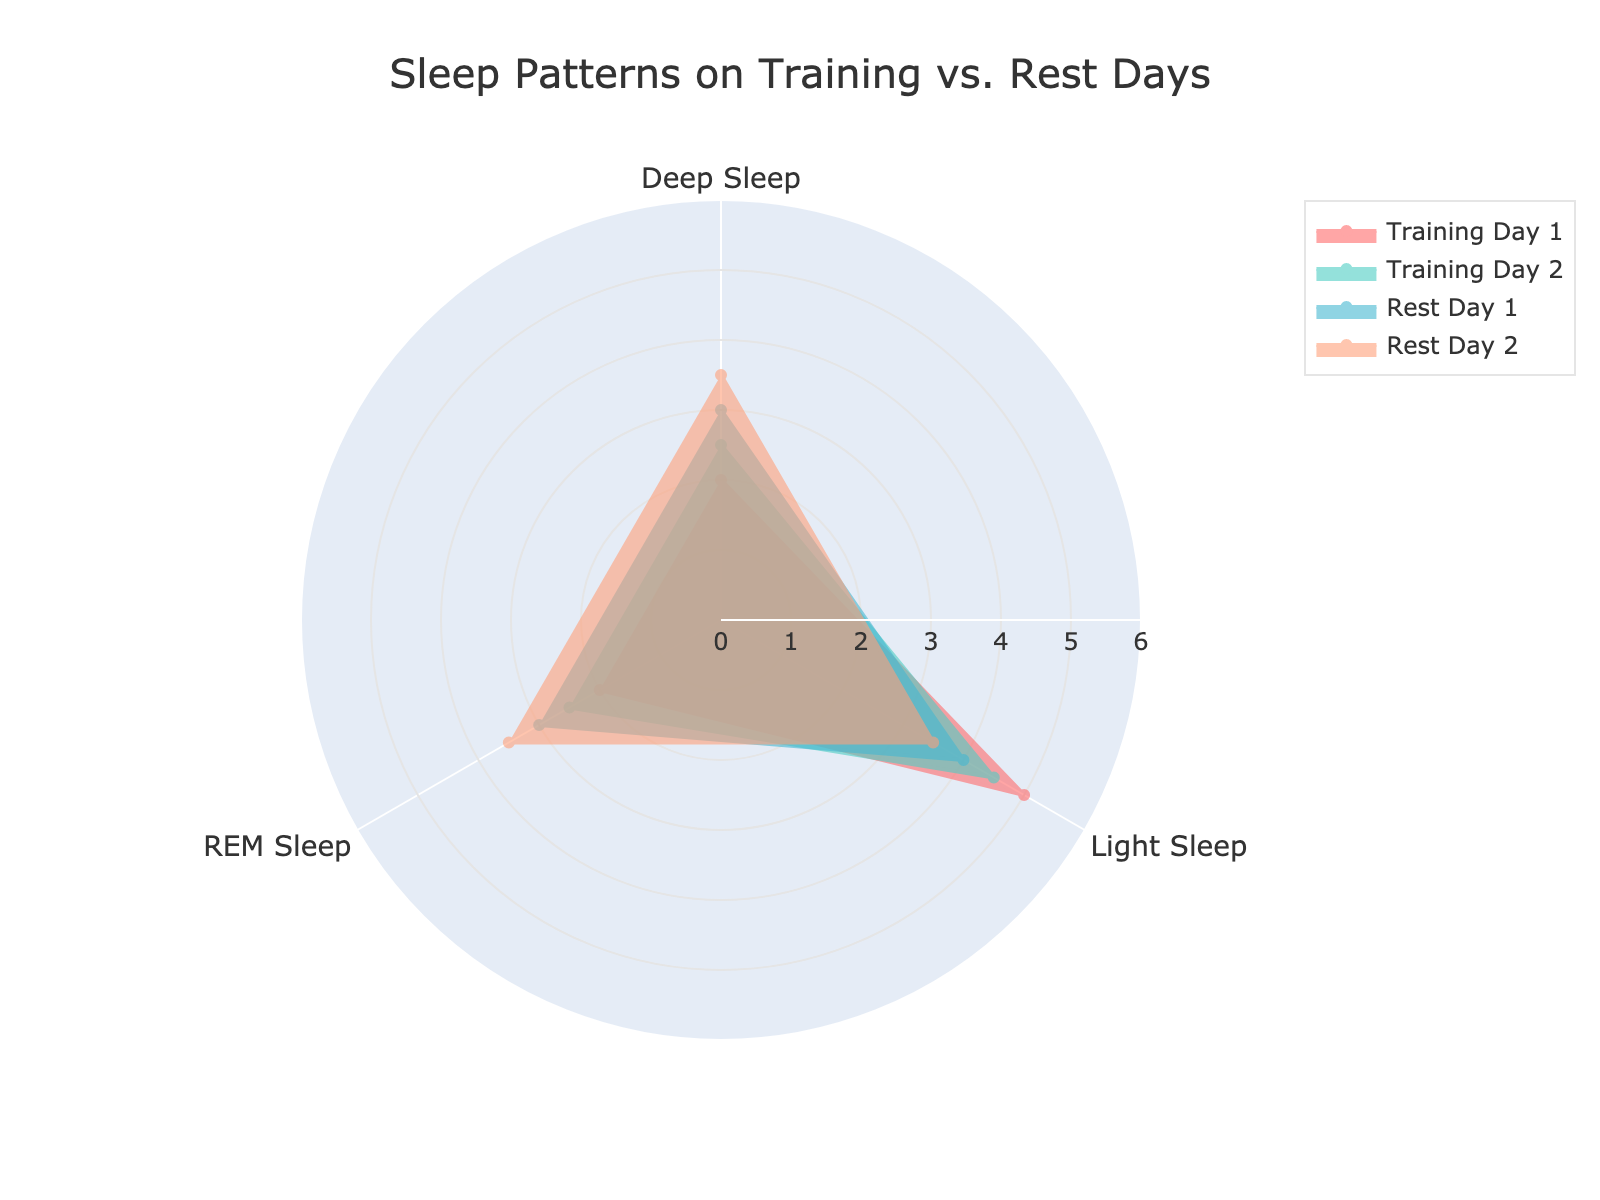what is the title of the chart? The title of the chart is located at the top and is used to describe what the chart represents. By looking at the figure, the chart's title can be read directly.
Answer: Sleep Patterns on Training vs. Rest Days How many groups of days are represented in the chart? The groups of days are depicted by different colored filled areas on the radar chart. By counting these areas, we can determine the number of groups.
Answer: Four Which sleep type shows the greatest difference between Training Day 1 and Rest Day 2? To find the greatest difference, compare the values for all sleep types between Training Day 1 and Rest Day 2. The largest difference is evident in Deep Sleep (2.0 vs. 3.5 = difference of 1.5).
Answer: Deep Sleep What are the average values of REM Sleep for Training Days and Rest Days? Calculate the average by summing the REM Sleep values for Training and Rest Days separately and dividing by the number of days in each category. For Training Days (2.0 + 2.5) / 2 = 2.25. For Rest Days (3.0 + 3.5) / 2 = 3.25.
Answer: Training Days: 2.25, Rest Days: 3.25 Which day shows the highest amount of Light Sleep? Look at the values for Light Sleep across all days and identify the highest value. Training Day 1 has the highest amount of Light Sleep at 5.0.
Answer: Training Day 1 How does the REM Sleep on Training Day 2 compare to Rest Day 1? Compare the REM Sleep values for Training Day 2 and Rest Day 1. Training Day 2 has 2.5, and Rest Day 1 has 3.0. Therefore, Training Day 2 has less REM Sleep.
Answer: Less Which day exhibited the least amount of Deep Sleep? Identify the smallest value in the Deep Sleep category across all days. Training Day 1 has the least Deep Sleep at 2.0 hours.
Answer: Training Day 1 What is the sum of Light Sleep for all days? Add the Light Sleep values for each day. The sum is 5.0 + 4.5 + 4.0 + 3.5 = 17.0 hours.
Answer: 17.0 hours Are there any days with identical REM Sleep values? Compare the REM Sleep values for all days to identify if any of them are the same. All values are different, i.e., 2.0, 2.5, 3.0, and 3.5.
Answer: No 